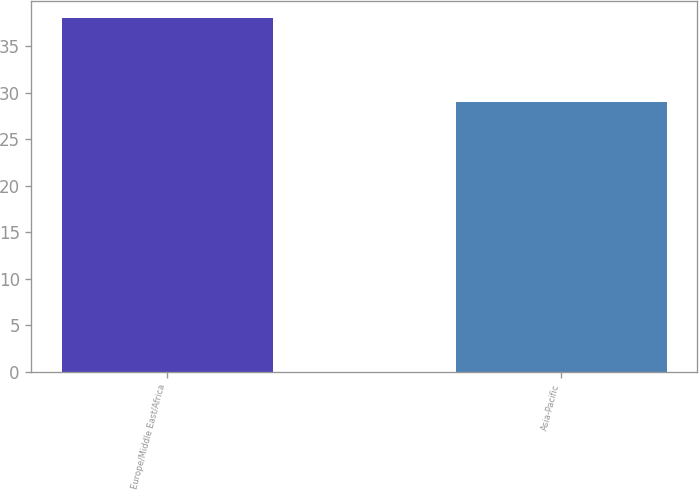Convert chart to OTSL. <chart><loc_0><loc_0><loc_500><loc_500><bar_chart><fcel>Europe/Middle East/Africa<fcel>Asia-Pacific<nl><fcel>38<fcel>29<nl></chart> 